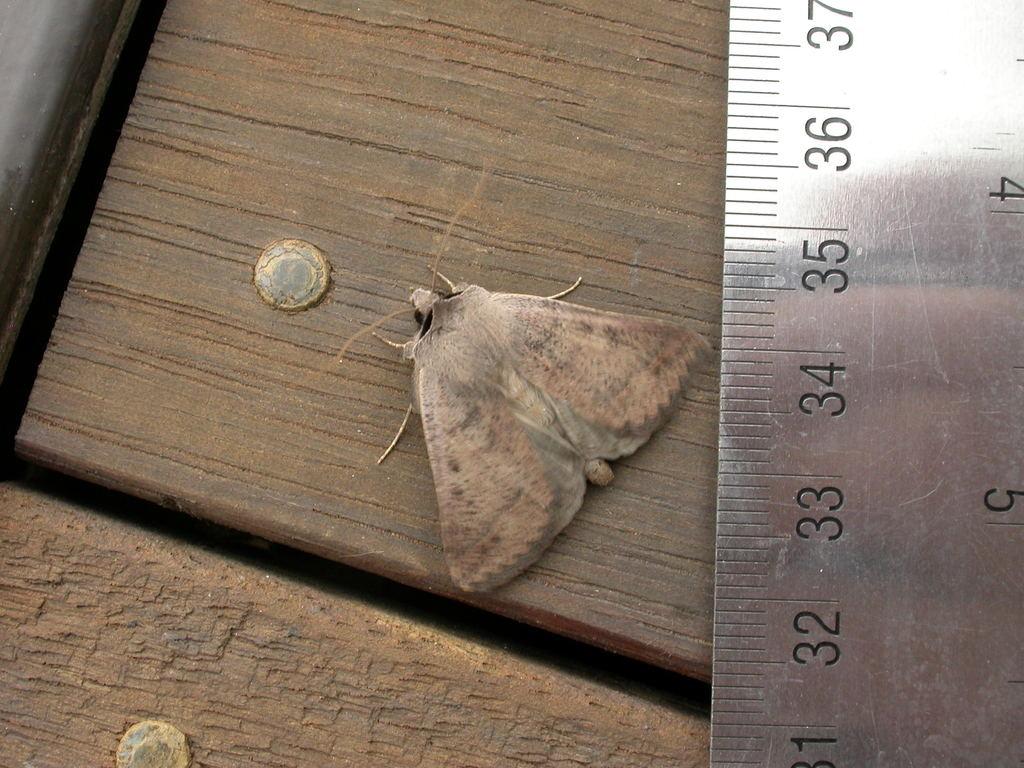What is the number at the top of the ruler?
Offer a terse response. 37. What is the number at the bottom of the ruler?
Your response must be concise. 31. 